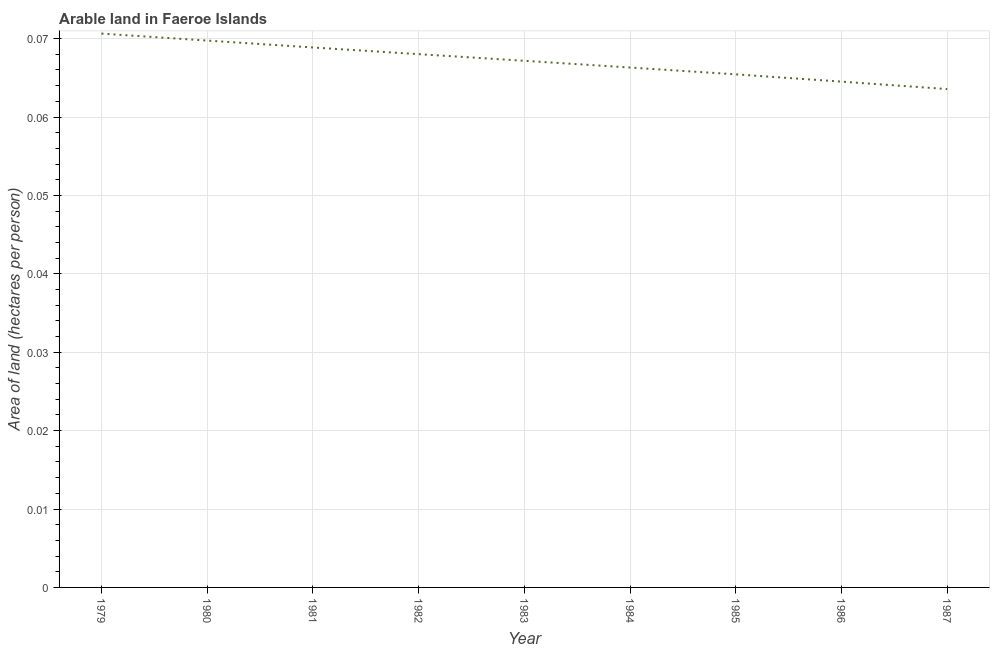What is the area of arable land in 1982?
Offer a terse response. 0.07. Across all years, what is the maximum area of arable land?
Provide a short and direct response. 0.07. Across all years, what is the minimum area of arable land?
Provide a succinct answer. 0.06. In which year was the area of arable land maximum?
Offer a terse response. 1979. What is the sum of the area of arable land?
Provide a succinct answer. 0.6. What is the difference between the area of arable land in 1980 and 1983?
Offer a very short reply. 0. What is the average area of arable land per year?
Provide a succinct answer. 0.07. What is the median area of arable land?
Give a very brief answer. 0.07. In how many years, is the area of arable land greater than 0.012 hectares per person?
Your response must be concise. 9. Do a majority of the years between 1979 and 1982 (inclusive) have area of arable land greater than 0.018000000000000002 hectares per person?
Keep it short and to the point. Yes. What is the ratio of the area of arable land in 1981 to that in 1987?
Provide a succinct answer. 1.08. Is the area of arable land in 1981 less than that in 1986?
Keep it short and to the point. No. Is the difference between the area of arable land in 1982 and 1985 greater than the difference between any two years?
Offer a very short reply. No. What is the difference between the highest and the second highest area of arable land?
Offer a very short reply. 0. Is the sum of the area of arable land in 1980 and 1987 greater than the maximum area of arable land across all years?
Provide a short and direct response. Yes. What is the difference between the highest and the lowest area of arable land?
Provide a succinct answer. 0.01. How many lines are there?
Offer a terse response. 1. What is the difference between two consecutive major ticks on the Y-axis?
Make the answer very short. 0.01. Are the values on the major ticks of Y-axis written in scientific E-notation?
Keep it short and to the point. No. Does the graph contain grids?
Keep it short and to the point. Yes. What is the title of the graph?
Provide a succinct answer. Arable land in Faeroe Islands. What is the label or title of the X-axis?
Offer a very short reply. Year. What is the label or title of the Y-axis?
Your answer should be compact. Area of land (hectares per person). What is the Area of land (hectares per person) in 1979?
Provide a succinct answer. 0.07. What is the Area of land (hectares per person) in 1980?
Your answer should be compact. 0.07. What is the Area of land (hectares per person) of 1981?
Your answer should be compact. 0.07. What is the Area of land (hectares per person) of 1982?
Provide a short and direct response. 0.07. What is the Area of land (hectares per person) of 1983?
Provide a succinct answer. 0.07. What is the Area of land (hectares per person) in 1984?
Give a very brief answer. 0.07. What is the Area of land (hectares per person) of 1985?
Ensure brevity in your answer.  0.07. What is the Area of land (hectares per person) of 1986?
Your answer should be very brief. 0.06. What is the Area of land (hectares per person) of 1987?
Provide a succinct answer. 0.06. What is the difference between the Area of land (hectares per person) in 1979 and 1980?
Give a very brief answer. 0. What is the difference between the Area of land (hectares per person) in 1979 and 1981?
Give a very brief answer. 0. What is the difference between the Area of land (hectares per person) in 1979 and 1982?
Keep it short and to the point. 0. What is the difference between the Area of land (hectares per person) in 1979 and 1983?
Provide a succinct answer. 0. What is the difference between the Area of land (hectares per person) in 1979 and 1984?
Give a very brief answer. 0. What is the difference between the Area of land (hectares per person) in 1979 and 1985?
Your answer should be very brief. 0.01. What is the difference between the Area of land (hectares per person) in 1979 and 1986?
Your response must be concise. 0.01. What is the difference between the Area of land (hectares per person) in 1979 and 1987?
Your response must be concise. 0.01. What is the difference between the Area of land (hectares per person) in 1980 and 1981?
Provide a succinct answer. 0. What is the difference between the Area of land (hectares per person) in 1980 and 1982?
Your answer should be very brief. 0. What is the difference between the Area of land (hectares per person) in 1980 and 1983?
Keep it short and to the point. 0. What is the difference between the Area of land (hectares per person) in 1980 and 1984?
Offer a terse response. 0. What is the difference between the Area of land (hectares per person) in 1980 and 1985?
Your answer should be very brief. 0. What is the difference between the Area of land (hectares per person) in 1980 and 1986?
Keep it short and to the point. 0.01. What is the difference between the Area of land (hectares per person) in 1980 and 1987?
Your answer should be compact. 0.01. What is the difference between the Area of land (hectares per person) in 1981 and 1982?
Your response must be concise. 0. What is the difference between the Area of land (hectares per person) in 1981 and 1983?
Provide a succinct answer. 0. What is the difference between the Area of land (hectares per person) in 1981 and 1984?
Give a very brief answer. 0. What is the difference between the Area of land (hectares per person) in 1981 and 1985?
Your answer should be compact. 0. What is the difference between the Area of land (hectares per person) in 1981 and 1986?
Your answer should be very brief. 0. What is the difference between the Area of land (hectares per person) in 1981 and 1987?
Keep it short and to the point. 0.01. What is the difference between the Area of land (hectares per person) in 1982 and 1983?
Offer a terse response. 0. What is the difference between the Area of land (hectares per person) in 1982 and 1984?
Ensure brevity in your answer.  0. What is the difference between the Area of land (hectares per person) in 1982 and 1985?
Your answer should be very brief. 0. What is the difference between the Area of land (hectares per person) in 1982 and 1986?
Your answer should be compact. 0. What is the difference between the Area of land (hectares per person) in 1982 and 1987?
Keep it short and to the point. 0. What is the difference between the Area of land (hectares per person) in 1983 and 1984?
Give a very brief answer. 0. What is the difference between the Area of land (hectares per person) in 1983 and 1985?
Your answer should be very brief. 0. What is the difference between the Area of land (hectares per person) in 1983 and 1986?
Give a very brief answer. 0. What is the difference between the Area of land (hectares per person) in 1983 and 1987?
Your answer should be compact. 0. What is the difference between the Area of land (hectares per person) in 1984 and 1985?
Ensure brevity in your answer.  0. What is the difference between the Area of land (hectares per person) in 1984 and 1986?
Your answer should be compact. 0. What is the difference between the Area of land (hectares per person) in 1984 and 1987?
Ensure brevity in your answer.  0. What is the difference between the Area of land (hectares per person) in 1985 and 1986?
Offer a very short reply. 0. What is the difference between the Area of land (hectares per person) in 1985 and 1987?
Offer a very short reply. 0. What is the difference between the Area of land (hectares per person) in 1986 and 1987?
Keep it short and to the point. 0. What is the ratio of the Area of land (hectares per person) in 1979 to that in 1980?
Ensure brevity in your answer.  1.01. What is the ratio of the Area of land (hectares per person) in 1979 to that in 1981?
Give a very brief answer. 1.03. What is the ratio of the Area of land (hectares per person) in 1979 to that in 1982?
Provide a short and direct response. 1.04. What is the ratio of the Area of land (hectares per person) in 1979 to that in 1983?
Give a very brief answer. 1.05. What is the ratio of the Area of land (hectares per person) in 1979 to that in 1984?
Keep it short and to the point. 1.06. What is the ratio of the Area of land (hectares per person) in 1979 to that in 1985?
Ensure brevity in your answer.  1.08. What is the ratio of the Area of land (hectares per person) in 1979 to that in 1986?
Offer a very short reply. 1.09. What is the ratio of the Area of land (hectares per person) in 1979 to that in 1987?
Your answer should be compact. 1.11. What is the ratio of the Area of land (hectares per person) in 1980 to that in 1982?
Ensure brevity in your answer.  1.02. What is the ratio of the Area of land (hectares per person) in 1980 to that in 1983?
Provide a succinct answer. 1.04. What is the ratio of the Area of land (hectares per person) in 1980 to that in 1984?
Ensure brevity in your answer.  1.05. What is the ratio of the Area of land (hectares per person) in 1980 to that in 1985?
Give a very brief answer. 1.07. What is the ratio of the Area of land (hectares per person) in 1980 to that in 1986?
Make the answer very short. 1.08. What is the ratio of the Area of land (hectares per person) in 1980 to that in 1987?
Keep it short and to the point. 1.1. What is the ratio of the Area of land (hectares per person) in 1981 to that in 1983?
Offer a very short reply. 1.02. What is the ratio of the Area of land (hectares per person) in 1981 to that in 1984?
Your answer should be compact. 1.04. What is the ratio of the Area of land (hectares per person) in 1981 to that in 1985?
Ensure brevity in your answer.  1.05. What is the ratio of the Area of land (hectares per person) in 1981 to that in 1986?
Your response must be concise. 1.07. What is the ratio of the Area of land (hectares per person) in 1981 to that in 1987?
Your answer should be very brief. 1.08. What is the ratio of the Area of land (hectares per person) in 1982 to that in 1983?
Ensure brevity in your answer.  1.01. What is the ratio of the Area of land (hectares per person) in 1982 to that in 1985?
Your response must be concise. 1.04. What is the ratio of the Area of land (hectares per person) in 1982 to that in 1986?
Offer a terse response. 1.05. What is the ratio of the Area of land (hectares per person) in 1982 to that in 1987?
Your answer should be very brief. 1.07. What is the ratio of the Area of land (hectares per person) in 1983 to that in 1986?
Your answer should be compact. 1.04. What is the ratio of the Area of land (hectares per person) in 1983 to that in 1987?
Your response must be concise. 1.06. What is the ratio of the Area of land (hectares per person) in 1984 to that in 1985?
Your response must be concise. 1.01. What is the ratio of the Area of land (hectares per person) in 1984 to that in 1986?
Make the answer very short. 1.03. What is the ratio of the Area of land (hectares per person) in 1984 to that in 1987?
Your answer should be very brief. 1.04. What is the ratio of the Area of land (hectares per person) in 1985 to that in 1987?
Provide a succinct answer. 1.03. What is the ratio of the Area of land (hectares per person) in 1986 to that in 1987?
Offer a terse response. 1.01. 